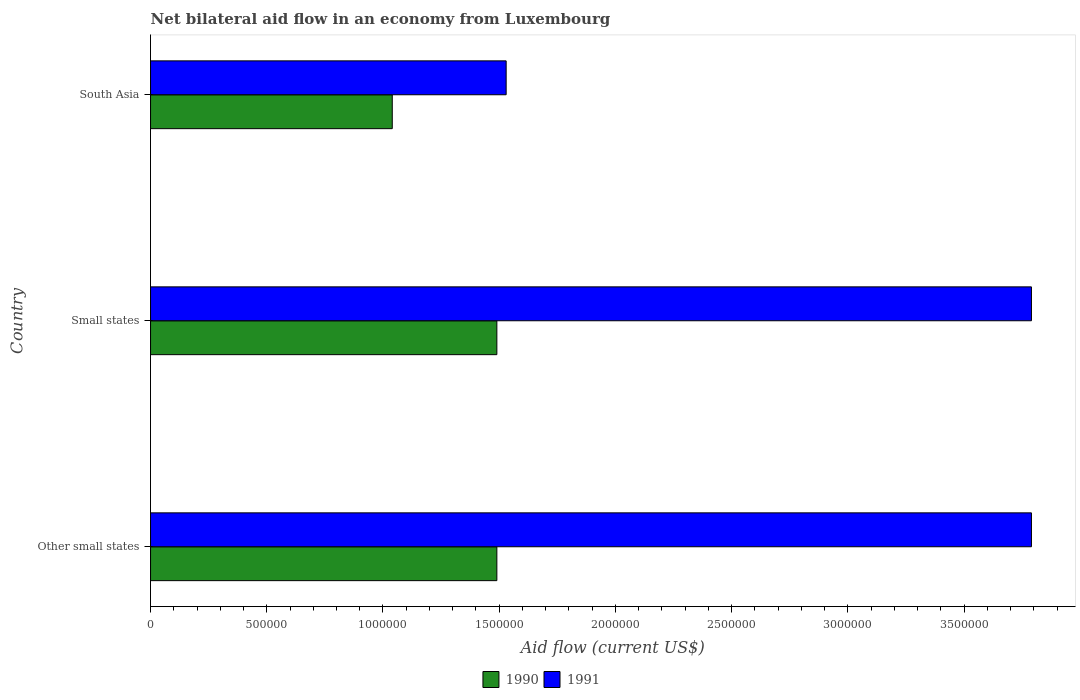Are the number of bars on each tick of the Y-axis equal?
Make the answer very short. Yes. How many bars are there on the 3rd tick from the top?
Keep it short and to the point. 2. How many bars are there on the 3rd tick from the bottom?
Provide a succinct answer. 2. What is the label of the 2nd group of bars from the top?
Ensure brevity in your answer.  Small states. In how many cases, is the number of bars for a given country not equal to the number of legend labels?
Offer a terse response. 0. What is the net bilateral aid flow in 1991 in Small states?
Offer a terse response. 3.79e+06. Across all countries, what is the maximum net bilateral aid flow in 1990?
Offer a very short reply. 1.49e+06. Across all countries, what is the minimum net bilateral aid flow in 1990?
Your response must be concise. 1.04e+06. In which country was the net bilateral aid flow in 1990 maximum?
Ensure brevity in your answer.  Other small states. In which country was the net bilateral aid flow in 1991 minimum?
Keep it short and to the point. South Asia. What is the total net bilateral aid flow in 1991 in the graph?
Offer a very short reply. 9.11e+06. What is the difference between the net bilateral aid flow in 1990 in South Asia and the net bilateral aid flow in 1991 in Small states?
Keep it short and to the point. -2.75e+06. What is the average net bilateral aid flow in 1991 per country?
Offer a terse response. 3.04e+06. What is the difference between the net bilateral aid flow in 1991 and net bilateral aid flow in 1990 in Other small states?
Keep it short and to the point. 2.30e+06. In how many countries, is the net bilateral aid flow in 1990 greater than 400000 US$?
Make the answer very short. 3. What is the ratio of the net bilateral aid flow in 1991 in Small states to that in South Asia?
Offer a terse response. 2.48. Is the net bilateral aid flow in 1990 in Other small states less than that in South Asia?
Keep it short and to the point. No. What is the difference between the highest and the lowest net bilateral aid flow in 1991?
Keep it short and to the point. 2.26e+06. In how many countries, is the net bilateral aid flow in 1991 greater than the average net bilateral aid flow in 1991 taken over all countries?
Provide a succinct answer. 2. How many bars are there?
Give a very brief answer. 6. Are all the bars in the graph horizontal?
Your answer should be compact. Yes. What is the difference between two consecutive major ticks on the X-axis?
Your answer should be very brief. 5.00e+05. Where does the legend appear in the graph?
Offer a very short reply. Bottom center. How are the legend labels stacked?
Offer a terse response. Horizontal. What is the title of the graph?
Your answer should be compact. Net bilateral aid flow in an economy from Luxembourg. What is the Aid flow (current US$) of 1990 in Other small states?
Your response must be concise. 1.49e+06. What is the Aid flow (current US$) of 1991 in Other small states?
Ensure brevity in your answer.  3.79e+06. What is the Aid flow (current US$) of 1990 in Small states?
Your answer should be very brief. 1.49e+06. What is the Aid flow (current US$) of 1991 in Small states?
Give a very brief answer. 3.79e+06. What is the Aid flow (current US$) of 1990 in South Asia?
Make the answer very short. 1.04e+06. What is the Aid flow (current US$) in 1991 in South Asia?
Your answer should be compact. 1.53e+06. Across all countries, what is the maximum Aid flow (current US$) of 1990?
Your response must be concise. 1.49e+06. Across all countries, what is the maximum Aid flow (current US$) of 1991?
Your answer should be compact. 3.79e+06. Across all countries, what is the minimum Aid flow (current US$) of 1990?
Keep it short and to the point. 1.04e+06. Across all countries, what is the minimum Aid flow (current US$) in 1991?
Offer a very short reply. 1.53e+06. What is the total Aid flow (current US$) in 1990 in the graph?
Give a very brief answer. 4.02e+06. What is the total Aid flow (current US$) in 1991 in the graph?
Offer a terse response. 9.11e+06. What is the difference between the Aid flow (current US$) in 1990 in Other small states and that in Small states?
Ensure brevity in your answer.  0. What is the difference between the Aid flow (current US$) in 1991 in Other small states and that in Small states?
Provide a succinct answer. 0. What is the difference between the Aid flow (current US$) in 1991 in Other small states and that in South Asia?
Make the answer very short. 2.26e+06. What is the difference between the Aid flow (current US$) in 1991 in Small states and that in South Asia?
Ensure brevity in your answer.  2.26e+06. What is the difference between the Aid flow (current US$) in 1990 in Other small states and the Aid flow (current US$) in 1991 in Small states?
Offer a very short reply. -2.30e+06. What is the difference between the Aid flow (current US$) of 1990 in Other small states and the Aid flow (current US$) of 1991 in South Asia?
Your answer should be compact. -4.00e+04. What is the difference between the Aid flow (current US$) in 1990 in Small states and the Aid flow (current US$) in 1991 in South Asia?
Keep it short and to the point. -4.00e+04. What is the average Aid flow (current US$) in 1990 per country?
Your response must be concise. 1.34e+06. What is the average Aid flow (current US$) of 1991 per country?
Offer a very short reply. 3.04e+06. What is the difference between the Aid flow (current US$) in 1990 and Aid flow (current US$) in 1991 in Other small states?
Your response must be concise. -2.30e+06. What is the difference between the Aid flow (current US$) in 1990 and Aid flow (current US$) in 1991 in Small states?
Give a very brief answer. -2.30e+06. What is the difference between the Aid flow (current US$) of 1990 and Aid flow (current US$) of 1991 in South Asia?
Your answer should be very brief. -4.90e+05. What is the ratio of the Aid flow (current US$) in 1990 in Other small states to that in South Asia?
Ensure brevity in your answer.  1.43. What is the ratio of the Aid flow (current US$) of 1991 in Other small states to that in South Asia?
Offer a terse response. 2.48. What is the ratio of the Aid flow (current US$) in 1990 in Small states to that in South Asia?
Your response must be concise. 1.43. What is the ratio of the Aid flow (current US$) in 1991 in Small states to that in South Asia?
Provide a short and direct response. 2.48. What is the difference between the highest and the second highest Aid flow (current US$) of 1991?
Your answer should be very brief. 0. What is the difference between the highest and the lowest Aid flow (current US$) of 1990?
Provide a short and direct response. 4.50e+05. What is the difference between the highest and the lowest Aid flow (current US$) of 1991?
Provide a succinct answer. 2.26e+06. 